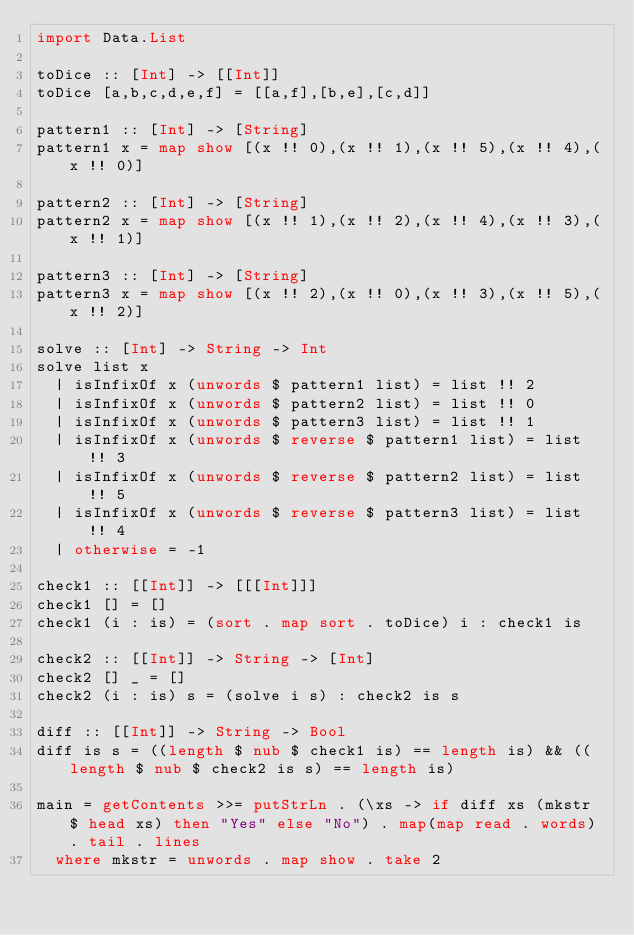<code> <loc_0><loc_0><loc_500><loc_500><_Haskell_>import Data.List
 
toDice :: [Int] -> [[Int]]
toDice [a,b,c,d,e,f] = [[a,f],[b,e],[c,d]]
 
pattern1 :: [Int] -> [String]
pattern1 x = map show [(x !! 0),(x !! 1),(x !! 5),(x !! 4),(x !! 0)]
 
pattern2 :: [Int] -> [String]
pattern2 x = map show [(x !! 1),(x !! 2),(x !! 4),(x !! 3),(x !! 1)]
 
pattern3 :: [Int] -> [String]
pattern3 x = map show [(x !! 2),(x !! 0),(x !! 3),(x !! 5),(x !! 2)]
 
solve :: [Int] -> String -> Int
solve list x
  | isInfixOf x (unwords $ pattern1 list) = list !! 2
  | isInfixOf x (unwords $ pattern2 list) = list !! 0
  | isInfixOf x (unwords $ pattern3 list) = list !! 1
  | isInfixOf x (unwords $ reverse $ pattern1 list) = list !! 3
  | isInfixOf x (unwords $ reverse $ pattern2 list) = list !! 5
  | isInfixOf x (unwords $ reverse $ pattern3 list) = list !! 4
  | otherwise = -1
 
check1 :: [[Int]] -> [[[Int]]]
check1 [] = []
check1 (i : is) = (sort . map sort . toDice) i : check1 is
 
check2 :: [[Int]] -> String -> [Int]
check2 [] _ = []
check2 (i : is) s = (solve i s) : check2 is s

diff :: [[Int]] -> String -> Bool
diff is s = ((length $ nub $ check1 is) == length is) && ((length $ nub $ check2 is s) == length is)
        
main = getContents >>= putStrLn . (\xs -> if diff xs (mkstr $ head xs) then "Yes" else "No") . map(map read . words) . tail . lines
  where mkstr = unwords . map show . take 2</code> 